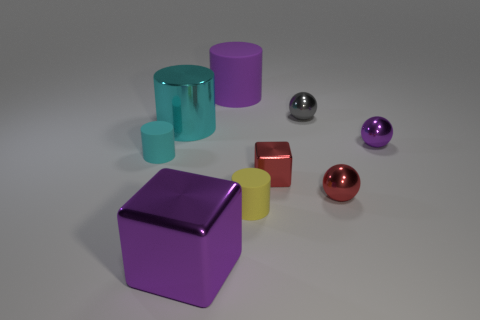Subtract all cyan cylinders. Subtract all cyan blocks. How many cylinders are left? 2 Add 1 small gray objects. How many objects exist? 10 Subtract all blocks. How many objects are left? 7 Subtract 0 brown spheres. How many objects are left? 9 Subtract all rubber cylinders. Subtract all red metal things. How many objects are left? 4 Add 9 big matte things. How many big matte things are left? 10 Add 7 blue metal cubes. How many blue metal cubes exist? 7 